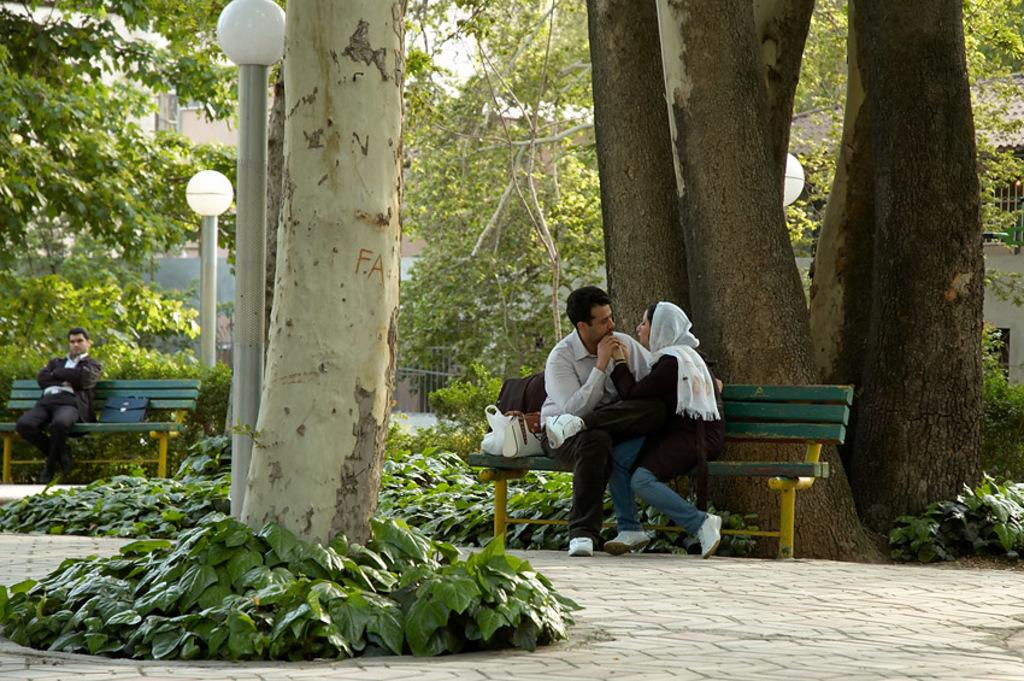How many people are present in the image? There are three people in the image. What can be seen on the benches in the image? There are bags on the benches in the image. What type of natural elements are visible in the image? There are plants and trees in the image. What type of structures can be seen in the image? There are poles and buildings in the image. What type of illumination is present in the image? There are lights in the image. What can be seen in the background of the image? There are buildings in the background of the image. What type of sweater is the duck wearing in the image? There is no duck or sweater present in the image. What type of spacecraft can be seen in the image? There is no spacecraft present in the image. 